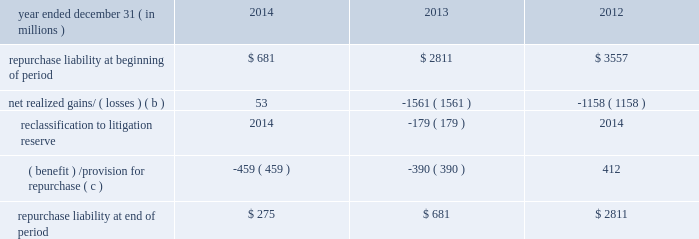Jpmorgan chase & co./2014 annual report 291 therefore , are not recorded on the consolidated balance sheets until settlement date .
The unsettled reverse repurchase agreements and securities borrowing agreements predominantly consist of agreements with regular-way settlement periods .
Loan sales- and securitization-related indemnifications mortgage repurchase liability in connection with the firm 2019s mortgage loan sale and securitization activities with the gses , as described in note 16 , the firm has made representations and warranties that the loans sold meet certain requirements .
The firm has been , and may be , required to repurchase loans and/or indemnify the gses ( e.g. , with 201cmake-whole 201d payments to reimburse the gses for their realized losses on liquidated loans ) .
To the extent that repurchase demands that are received relate to loans that the firm purchased from third parties that remain viable , the firm typically will have the right to seek a recovery of related repurchase losses from the third party .
Generally , the maximum amount of future payments the firm would be required to make for breaches of these representations and warranties would be equal to the unpaid principal balance of such loans that are deemed to have defects that were sold to purchasers ( including securitization-related spes ) plus , in certain circumstances , accrued interest on such loans and certain expense .
The table summarizes the change in the mortgage repurchase liability for each of the periods presented .
Summary of changes in mortgage repurchase liability ( a ) year ended december 31 , ( in millions ) 2014 2013 2012 repurchase liability at beginning of period $ 681 $ 2811 $ 3557 net realized gains/ ( losses ) ( b ) 53 ( 1561 ) ( 1158 ) .
( benefit ) /provision for repurchase ( c ) ( 459 ) ( 390 ) 412 repurchase liability at end of period $ 275 $ 681 $ 2811 ( a ) on october 25 , 2013 , the firm announced that it had reached a $ 1.1 billion agreement with the fhfa to resolve , other than certain limited types of exposures , outstanding and future mortgage repurchase demands associated with loans sold to the gses from 2000 to 2008 .
( b ) presented net of third-party recoveries and included principal losses and accrued interest on repurchased loans , 201cmake-whole 201d settlements , settlements with claimants , and certain related expense .
Make-whole settlements were $ 11 million , $ 414 million and $ 524 million , for the years ended december 31 , 2014 , 2013 and 2012 , respectively .
( c ) included a provision related to new loan sales of $ 4 million , $ 20 million and $ 112 million , for the years ended december 31 , 2014 , 2013 and 2012 , respectively .
Private label securitizations the liability related to repurchase demands associated with private label securitizations is separately evaluated by the firm in establishing its litigation reserves .
On november 15 , 2013 , the firm announced that it had reached a $ 4.5 billion agreement with 21 major institutional investors to make a binding offer to the trustees of 330 residential mortgage-backed securities trusts issued by j.p.morgan , chase , and bear stearns ( 201crmbs trust settlement 201d ) to resolve all representation and warranty claims , as well as all servicing claims , on all trusts issued by j.p .
Morgan , chase , and bear stearns between 2005 and 2008 .
The seven trustees ( or separate and successor trustees ) for this group of 330 trusts have accepted the rmbs trust settlement for 319 trusts in whole or in part and excluded from the settlement 16 trusts in whole or in part .
The trustees 2019 acceptance is subject to a judicial approval proceeding initiated by the trustees , which is pending in new york state court .
In addition , from 2005 to 2008 , washington mutual made certain loan level representations and warranties in connection with approximately $ 165 billion of residential mortgage loans that were originally sold or deposited into private-label securitizations by washington mutual .
Of the $ 165 billion , approximately $ 78 billion has been repaid .
In addition , approximately $ 49 billion of the principal amount of such loans has liquidated with an average loss severity of 59% ( 59 % ) .
Accordingly , the remaining outstanding principal balance of these loans as of december 31 , 2014 , was approximately $ 38 billion , of which $ 8 billion was 60 days or more past due .
The firm believes that any repurchase obligations related to these loans remain with the fdic receivership .
For additional information regarding litigation , see note 31 .
Loans sold with recourse the firm provides servicing for mortgages and certain commercial lending products on both a recourse and nonrecourse basis .
In nonrecourse servicing , the principal credit risk to the firm is the cost of temporary servicing advances of funds ( i.e. , normal servicing advances ) .
In recourse servicing , the servicer agrees to share credit risk with the owner of the mortgage loans , such as fannie mae or freddie mac or a private investor , insurer or guarantor .
Losses on recourse servicing predominantly occur when foreclosure sales proceeds of the property underlying a defaulted loan are less than the sum of the outstanding principal balance , plus accrued interest on the loan and the cost of holding and disposing of the underlying property .
The firm 2019s securitizations are predominantly nonrecourse , thereby effectively transferring the risk of future credit losses to the purchaser of the mortgage-backed securities issued by the trust .
At december 31 , 2014 and 2013 , the unpaid principal balance of loans sold with recourse totaled $ 6.1 billion and $ 7.7 billion , respectively .
The carrying value of the related liability that the firm has recorded , which is representative of the firm 2019s view of the likelihood it .
What did the make-whole settlements increase the total repurchase liability at the end of the period in 2012? 
Rationale: the net of third-party recoveries and included principal losses and accrued interest on repurchased loans would increase the total amount of money .
Computations: (2811 + 524)
Answer: 3335.0. Jpmorgan chase & co./2014 annual report 291 therefore , are not recorded on the consolidated balance sheets until settlement date .
The unsettled reverse repurchase agreements and securities borrowing agreements predominantly consist of agreements with regular-way settlement periods .
Loan sales- and securitization-related indemnifications mortgage repurchase liability in connection with the firm 2019s mortgage loan sale and securitization activities with the gses , as described in note 16 , the firm has made representations and warranties that the loans sold meet certain requirements .
The firm has been , and may be , required to repurchase loans and/or indemnify the gses ( e.g. , with 201cmake-whole 201d payments to reimburse the gses for their realized losses on liquidated loans ) .
To the extent that repurchase demands that are received relate to loans that the firm purchased from third parties that remain viable , the firm typically will have the right to seek a recovery of related repurchase losses from the third party .
Generally , the maximum amount of future payments the firm would be required to make for breaches of these representations and warranties would be equal to the unpaid principal balance of such loans that are deemed to have defects that were sold to purchasers ( including securitization-related spes ) plus , in certain circumstances , accrued interest on such loans and certain expense .
The table summarizes the change in the mortgage repurchase liability for each of the periods presented .
Summary of changes in mortgage repurchase liability ( a ) year ended december 31 , ( in millions ) 2014 2013 2012 repurchase liability at beginning of period $ 681 $ 2811 $ 3557 net realized gains/ ( losses ) ( b ) 53 ( 1561 ) ( 1158 ) .
( benefit ) /provision for repurchase ( c ) ( 459 ) ( 390 ) 412 repurchase liability at end of period $ 275 $ 681 $ 2811 ( a ) on october 25 , 2013 , the firm announced that it had reached a $ 1.1 billion agreement with the fhfa to resolve , other than certain limited types of exposures , outstanding and future mortgage repurchase demands associated with loans sold to the gses from 2000 to 2008 .
( b ) presented net of third-party recoveries and included principal losses and accrued interest on repurchased loans , 201cmake-whole 201d settlements , settlements with claimants , and certain related expense .
Make-whole settlements were $ 11 million , $ 414 million and $ 524 million , for the years ended december 31 , 2014 , 2013 and 2012 , respectively .
( c ) included a provision related to new loan sales of $ 4 million , $ 20 million and $ 112 million , for the years ended december 31 , 2014 , 2013 and 2012 , respectively .
Private label securitizations the liability related to repurchase demands associated with private label securitizations is separately evaluated by the firm in establishing its litigation reserves .
On november 15 , 2013 , the firm announced that it had reached a $ 4.5 billion agreement with 21 major institutional investors to make a binding offer to the trustees of 330 residential mortgage-backed securities trusts issued by j.p.morgan , chase , and bear stearns ( 201crmbs trust settlement 201d ) to resolve all representation and warranty claims , as well as all servicing claims , on all trusts issued by j.p .
Morgan , chase , and bear stearns between 2005 and 2008 .
The seven trustees ( or separate and successor trustees ) for this group of 330 trusts have accepted the rmbs trust settlement for 319 trusts in whole or in part and excluded from the settlement 16 trusts in whole or in part .
The trustees 2019 acceptance is subject to a judicial approval proceeding initiated by the trustees , which is pending in new york state court .
In addition , from 2005 to 2008 , washington mutual made certain loan level representations and warranties in connection with approximately $ 165 billion of residential mortgage loans that were originally sold or deposited into private-label securitizations by washington mutual .
Of the $ 165 billion , approximately $ 78 billion has been repaid .
In addition , approximately $ 49 billion of the principal amount of such loans has liquidated with an average loss severity of 59% ( 59 % ) .
Accordingly , the remaining outstanding principal balance of these loans as of december 31 , 2014 , was approximately $ 38 billion , of which $ 8 billion was 60 days or more past due .
The firm believes that any repurchase obligations related to these loans remain with the fdic receivership .
For additional information regarding litigation , see note 31 .
Loans sold with recourse the firm provides servicing for mortgages and certain commercial lending products on both a recourse and nonrecourse basis .
In nonrecourse servicing , the principal credit risk to the firm is the cost of temporary servicing advances of funds ( i.e. , normal servicing advances ) .
In recourse servicing , the servicer agrees to share credit risk with the owner of the mortgage loans , such as fannie mae or freddie mac or a private investor , insurer or guarantor .
Losses on recourse servicing predominantly occur when foreclosure sales proceeds of the property underlying a defaulted loan are less than the sum of the outstanding principal balance , plus accrued interest on the loan and the cost of holding and disposing of the underlying property .
The firm 2019s securitizations are predominantly nonrecourse , thereby effectively transferring the risk of future credit losses to the purchaser of the mortgage-backed securities issued by the trust .
At december 31 , 2014 and 2013 , the unpaid principal balance of loans sold with recourse totaled $ 6.1 billion and $ 7.7 billion , respectively .
The carrying value of the related liability that the firm has recorded , which is representative of the firm 2019s view of the likelihood it .
Based on the summary of changes in mortgage repurchase liability what was the percent of the change in the repurchase liability? 
Computations: ((275 - 681) / 681)
Answer: -0.59618. 